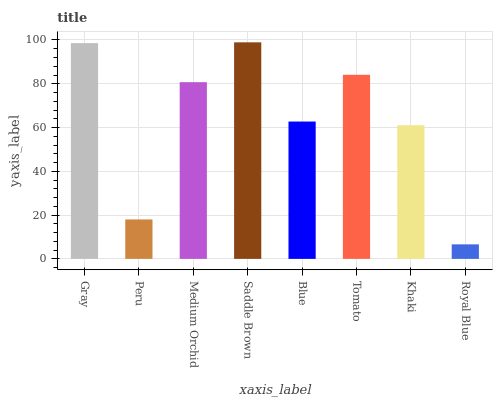Is Royal Blue the minimum?
Answer yes or no. Yes. Is Saddle Brown the maximum?
Answer yes or no. Yes. Is Peru the minimum?
Answer yes or no. No. Is Peru the maximum?
Answer yes or no. No. Is Gray greater than Peru?
Answer yes or no. Yes. Is Peru less than Gray?
Answer yes or no. Yes. Is Peru greater than Gray?
Answer yes or no. No. Is Gray less than Peru?
Answer yes or no. No. Is Medium Orchid the high median?
Answer yes or no. Yes. Is Blue the low median?
Answer yes or no. Yes. Is Gray the high median?
Answer yes or no. No. Is Peru the low median?
Answer yes or no. No. 